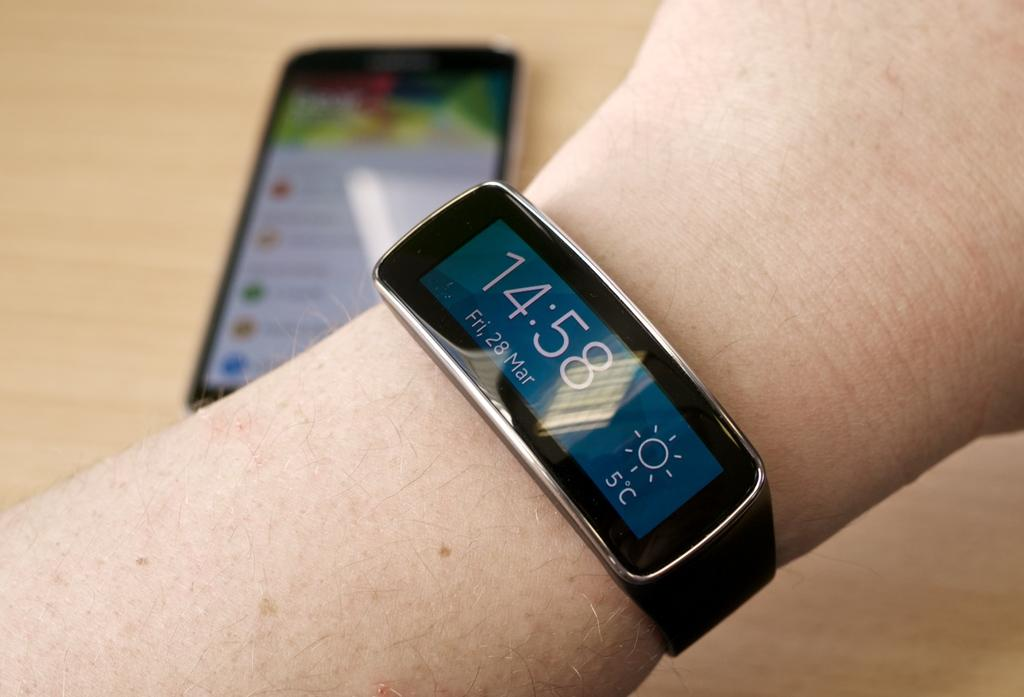Provide a one-sentence caption for the provided image. A person is wearing a watch that says the time is 14:58. 